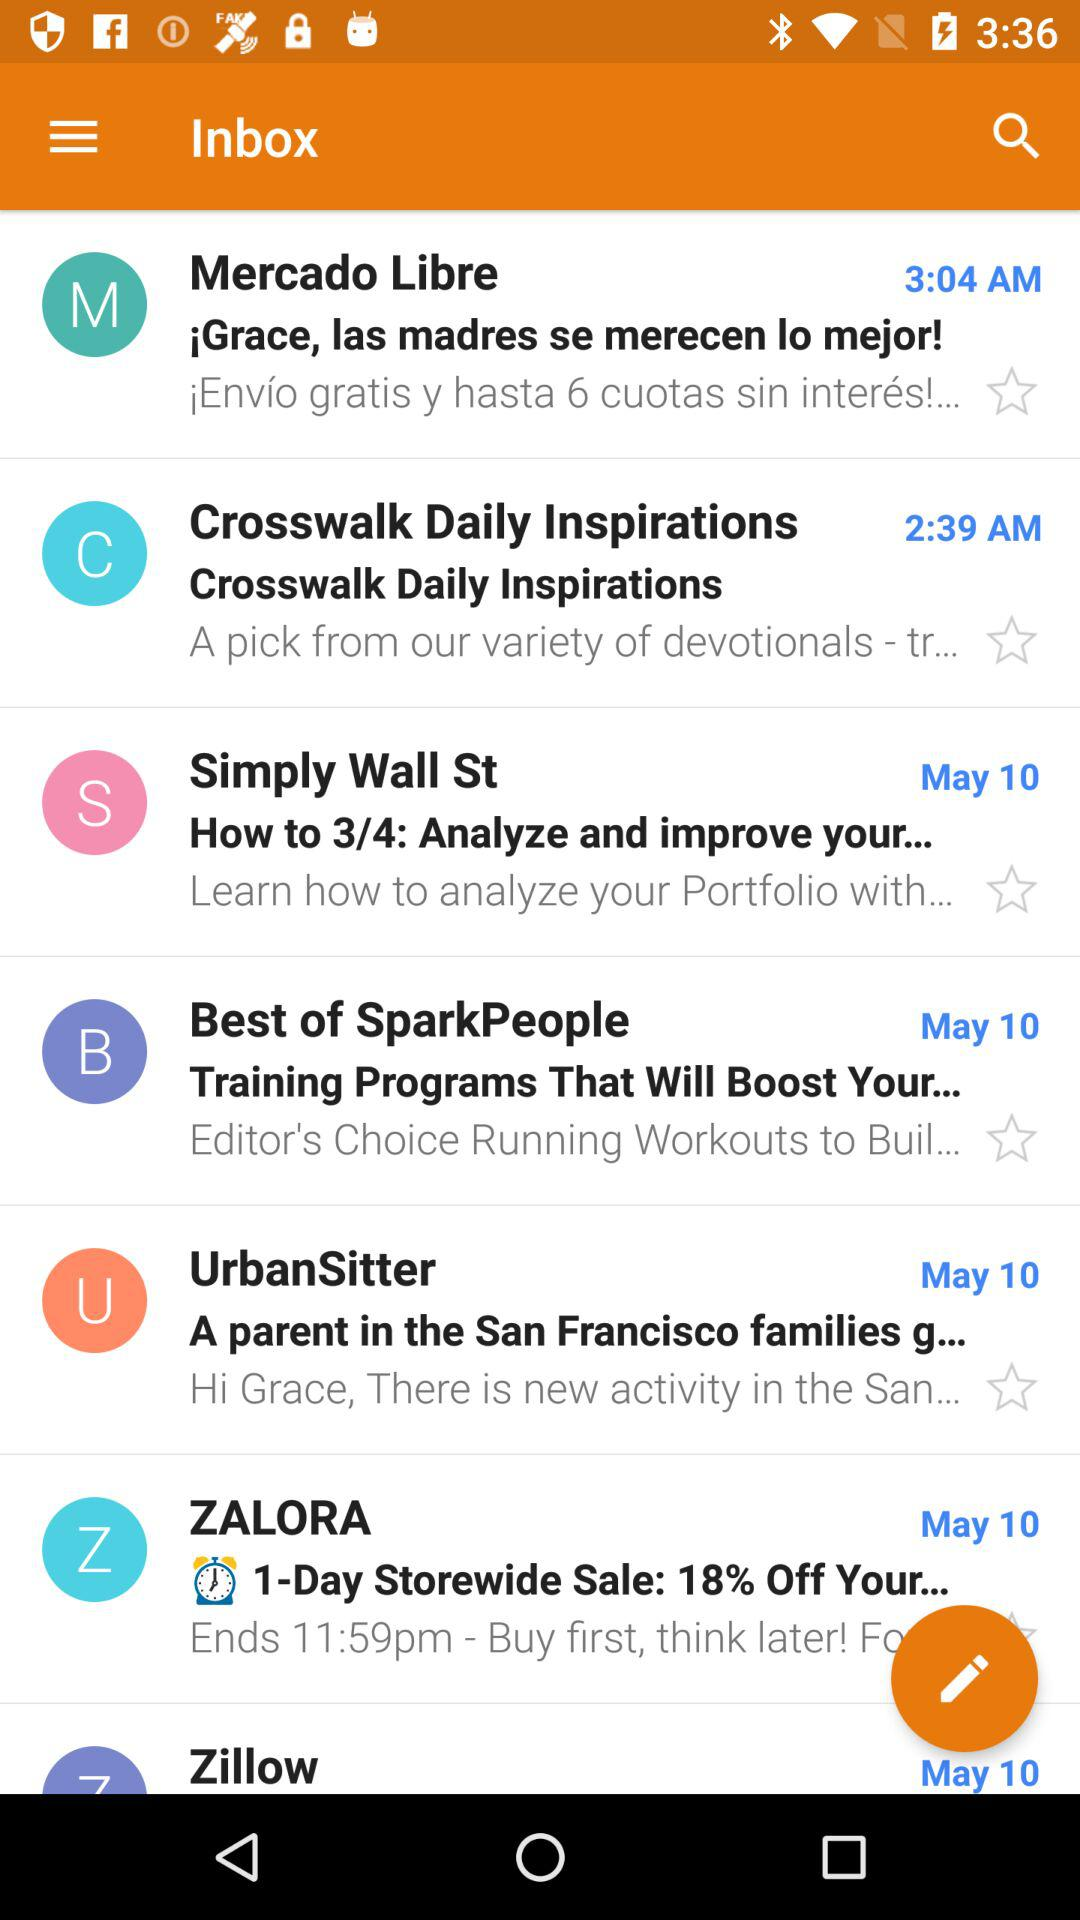What mail did I receive at 2:39 AM? The mail you received at 2:39 AM is "Crosswalk Daily Inspirations". 